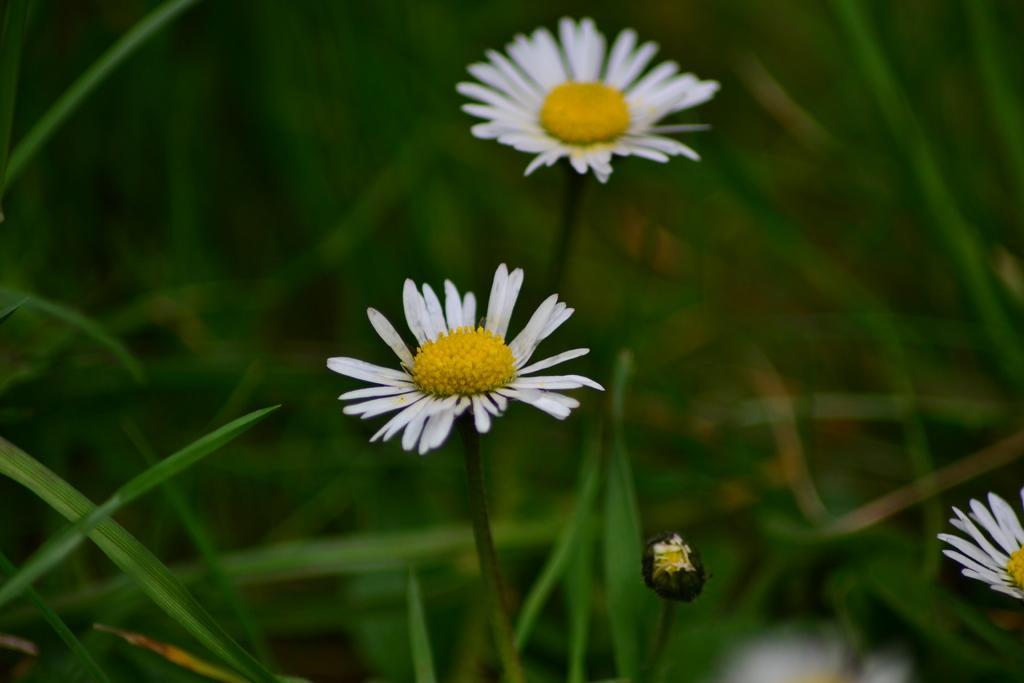Please provide a concise description of this image. In this picture we can observe two flowers which are in white and yellow color. We can observe grass in the background. 